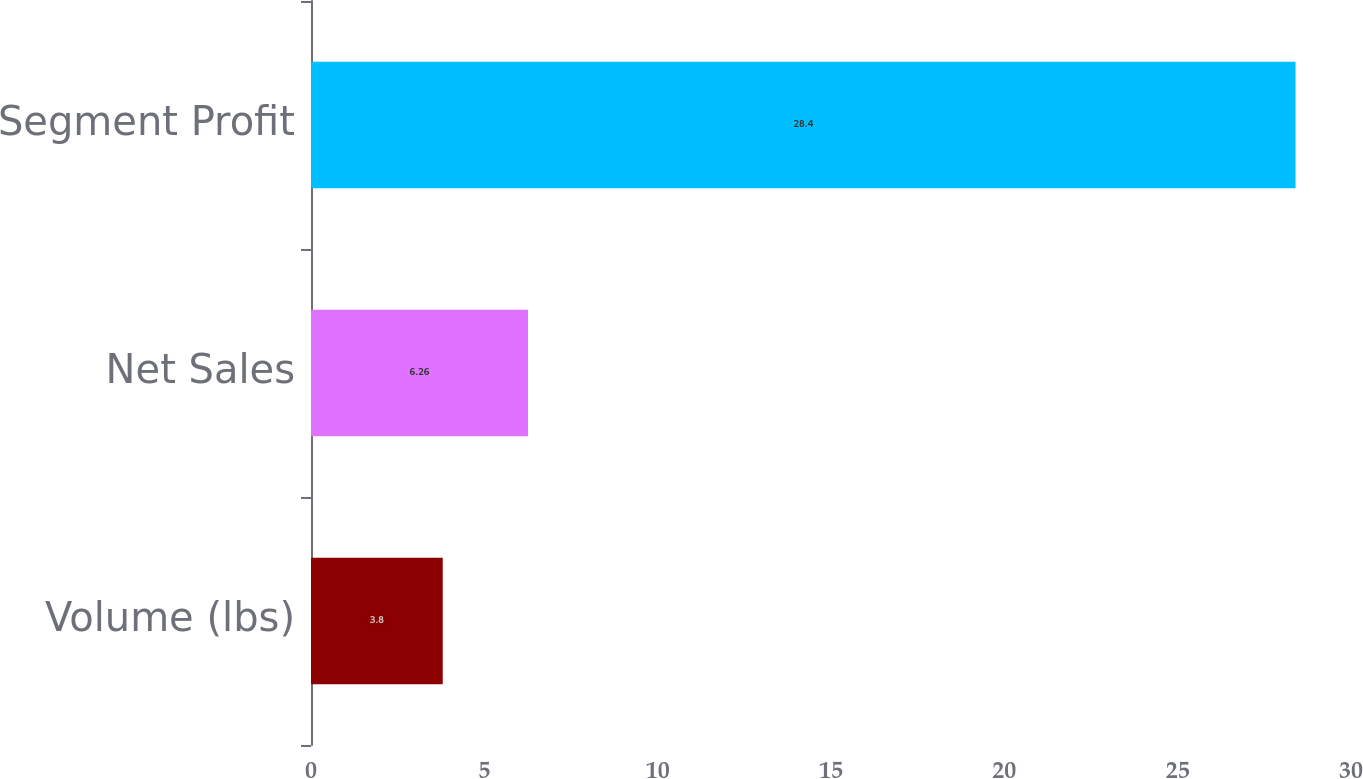Convert chart. <chart><loc_0><loc_0><loc_500><loc_500><bar_chart><fcel>Volume (lbs)<fcel>Net Sales<fcel>Segment Profit<nl><fcel>3.8<fcel>6.26<fcel>28.4<nl></chart> 